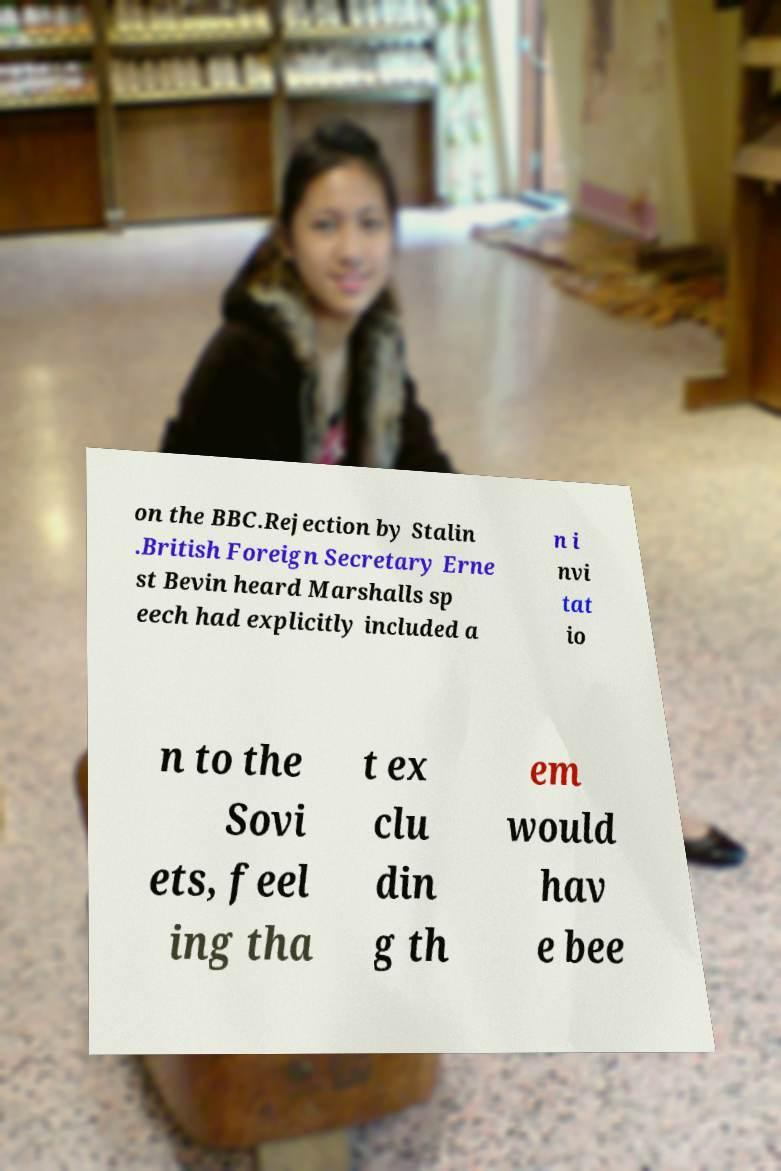Please read and relay the text visible in this image. What does it say? on the BBC.Rejection by Stalin .British Foreign Secretary Erne st Bevin heard Marshalls sp eech had explicitly included a n i nvi tat io n to the Sovi ets, feel ing tha t ex clu din g th em would hav e bee 